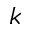Convert formula to latex. <formula><loc_0><loc_0><loc_500><loc_500>k</formula> 